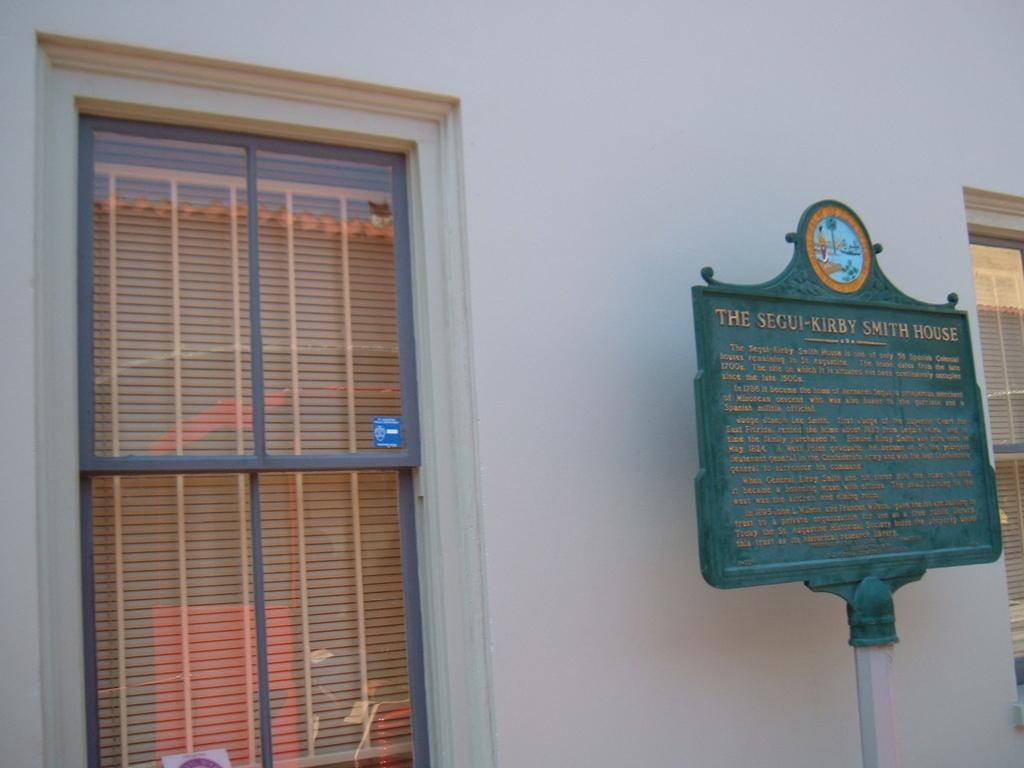<image>
Share a concise interpretation of the image provided. the segui kirby is written on a sign outside 